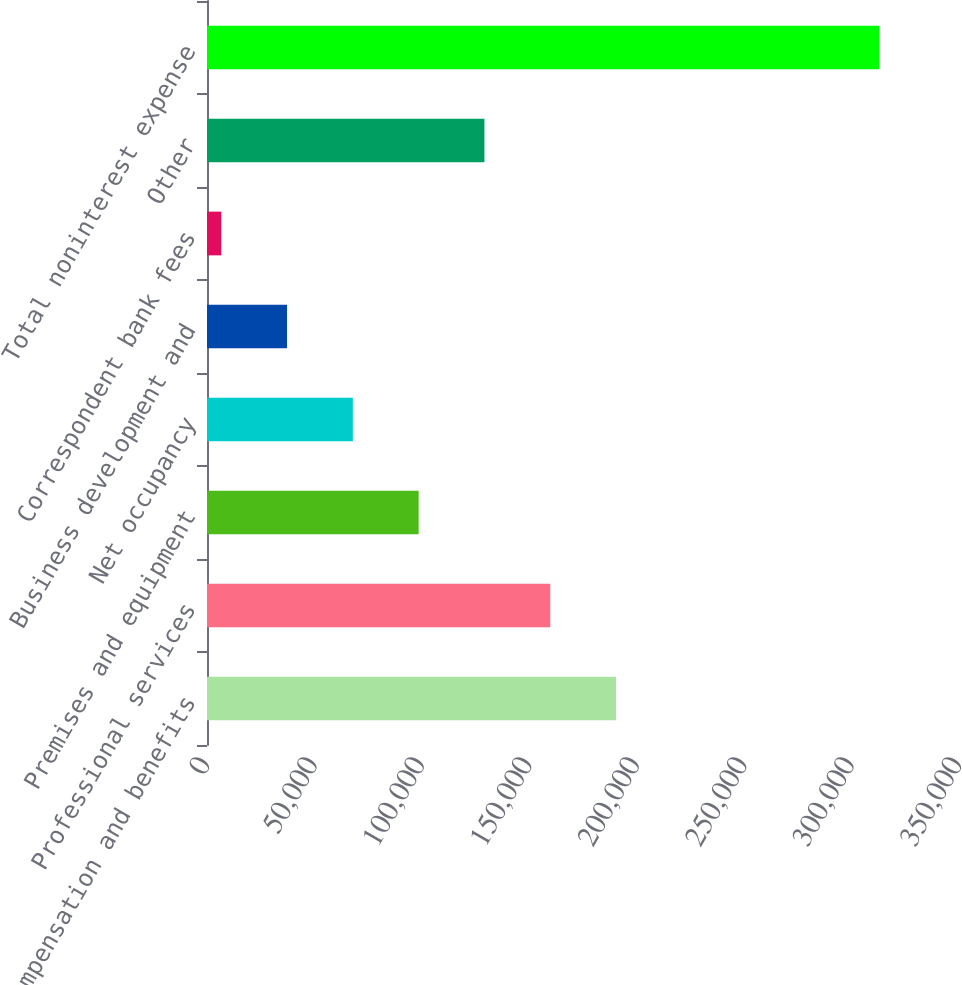Convert chart to OTSL. <chart><loc_0><loc_0><loc_500><loc_500><bar_chart><fcel>Compensation and benefits<fcel>Professional services<fcel>Premises and equipment<fcel>Net occupancy<fcel>Business development and<fcel>Correspondent bank fees<fcel>Other<fcel>Total noninterest expense<nl><fcel>190383<fcel>159758<fcel>98505.7<fcel>67879.8<fcel>37253.9<fcel>6628<fcel>129132<fcel>312887<nl></chart> 